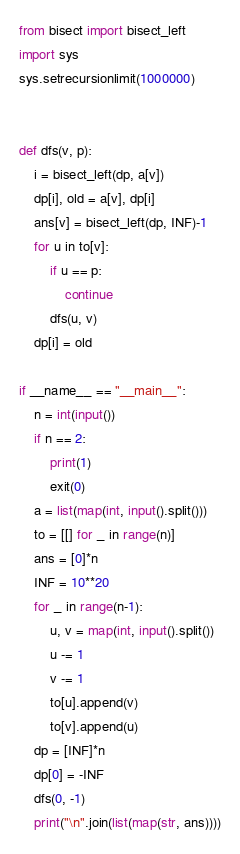Convert code to text. <code><loc_0><loc_0><loc_500><loc_500><_Python_>from bisect import bisect_left
import sys
sys.setrecursionlimit(1000000)


def dfs(v, p):
    i = bisect_left(dp, a[v])
    dp[i], old = a[v], dp[i]
    ans[v] = bisect_left(dp, INF)-1
    for u in to[v]:
        if u == p:
            continue
        dfs(u, v)
    dp[i] = old

if __name__ == "__main__":
    n = int(input())
    if n == 2:
        print(1)
        exit(0)
    a = list(map(int, input().split()))
    to = [[] for _ in range(n)]
    ans = [0]*n
    INF = 10**20
    for _ in range(n-1):
        u, v = map(int, input().split())
        u -= 1
        v -= 1
        to[u].append(v)
        to[v].append(u)
    dp = [INF]*n
    dp[0] = -INF
    dfs(0, -1)
    print("\n".join(list(map(str, ans))))</code> 